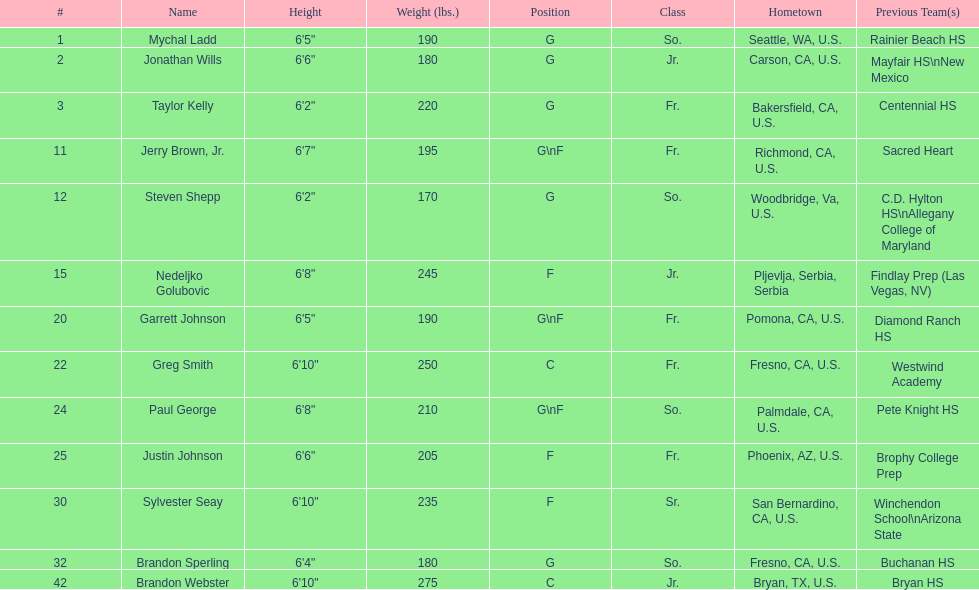Who is the heaviest member of the team? Brandon Webster. 